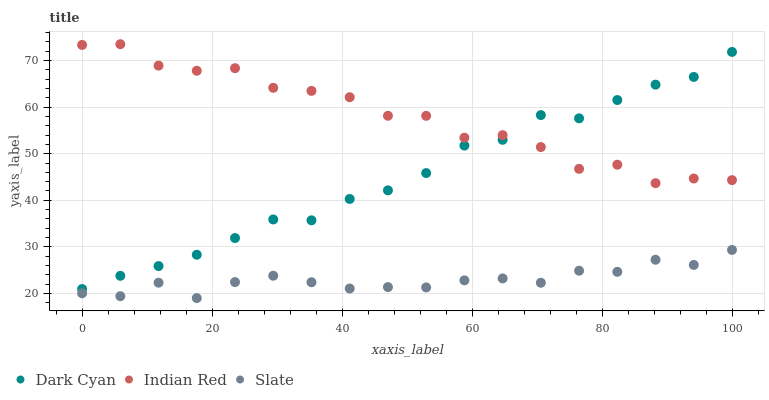Does Slate have the minimum area under the curve?
Answer yes or no. Yes. Does Indian Red have the maximum area under the curve?
Answer yes or no. Yes. Does Indian Red have the minimum area under the curve?
Answer yes or no. No. Does Slate have the maximum area under the curve?
Answer yes or no. No. Is Dark Cyan the smoothest?
Answer yes or no. Yes. Is Indian Red the roughest?
Answer yes or no. Yes. Is Slate the smoothest?
Answer yes or no. No. Is Slate the roughest?
Answer yes or no. No. Does Slate have the lowest value?
Answer yes or no. Yes. Does Indian Red have the lowest value?
Answer yes or no. No. Does Indian Red have the highest value?
Answer yes or no. Yes. Does Slate have the highest value?
Answer yes or no. No. Is Slate less than Indian Red?
Answer yes or no. Yes. Is Indian Red greater than Slate?
Answer yes or no. Yes. Does Dark Cyan intersect Indian Red?
Answer yes or no. Yes. Is Dark Cyan less than Indian Red?
Answer yes or no. No. Is Dark Cyan greater than Indian Red?
Answer yes or no. No. Does Slate intersect Indian Red?
Answer yes or no. No. 